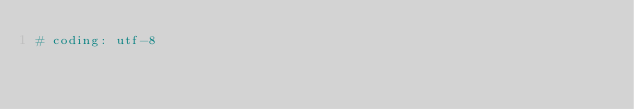Convert code to text. <code><loc_0><loc_0><loc_500><loc_500><_Python_># coding: utf-8</code> 